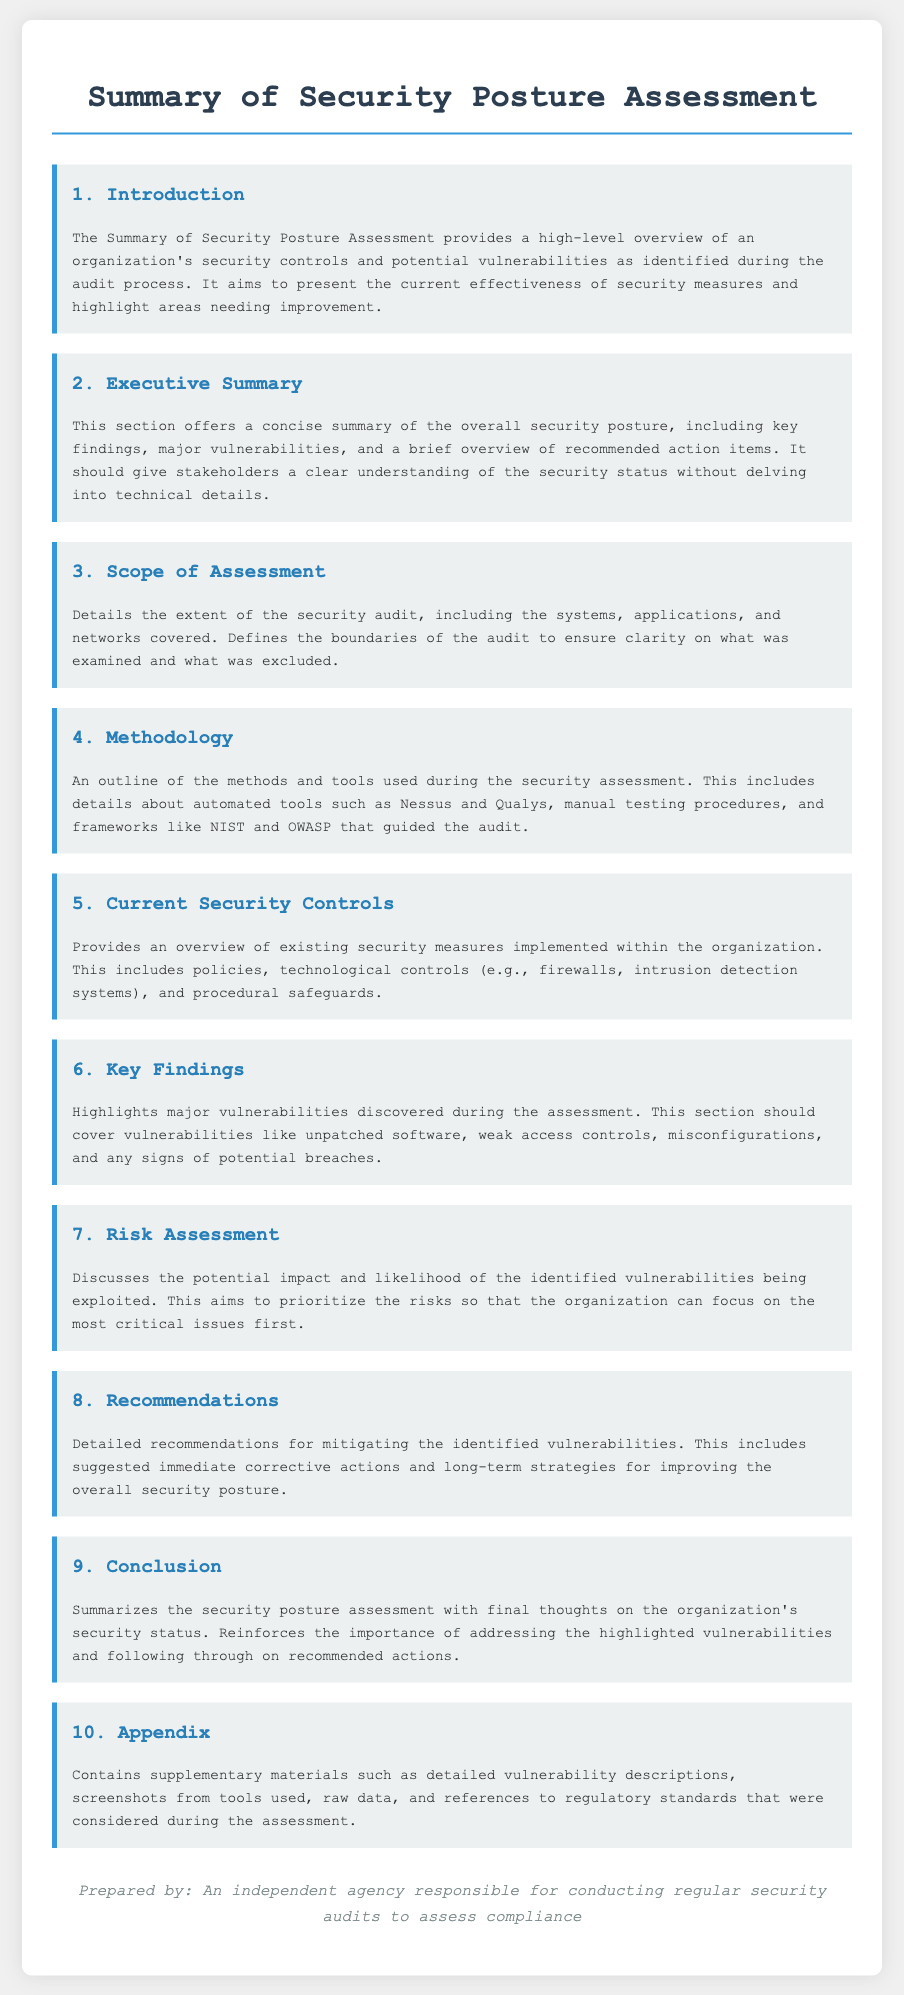What is the title of the document? The title is clearly stated at the top of the document, summarizing the focus on security posture assessment.
Answer: Summary of Security Posture Assessment How many sections are included in the document? The document lists ten distinct sections, each serving a specific purpose in the assessment.
Answer: 10 What is discussed in the Executive Summary section? This section provides a concise summary of overall security posture, including key findings and recommendations.
Answer: Key findings, major vulnerabilities, and recommended action items Which assessment methodologies are mentioned? The methodology section outlines the tools and frameworks used, indicating which specific methods were utilized in the assessment.
Answer: Nessus, Qualys, NIST, OWASP What does the 'Key Findings' section address? It highlights major vulnerabilities discovered during the security assessment, indicating the key focus of the findings.
Answer: Major vulnerabilities What is the purpose of the recommendations? The recommendations section serves to guide organizations on how to mitigate discovered vulnerabilities and improve security.
Answer: Mitigating identified vulnerabilities What does the Appendix contain? The appendix includes supplementary materials that provide additional context and detailed information related to the assessment.
Answer: Detailed vulnerability descriptions, screenshots, raw data, and references What is the agency responsible for preparing the document? The agency responsible for the document is mentioned at the end, providing clarity on who conducted the audits.
Answer: An independent agency What aspect of the document does the Risk Assessment section focus on? The Risk Assessment section discusses the potential impact and likelihood of vulnerabilities being exploited, thereby prioritizing risks.
Answer: Potential impact and likelihood of identified vulnerabilities What section provides an overview of current security controls? This section outlines the existing measures that organizations have implemented to secure their systems.
Answer: Current Security Controls 